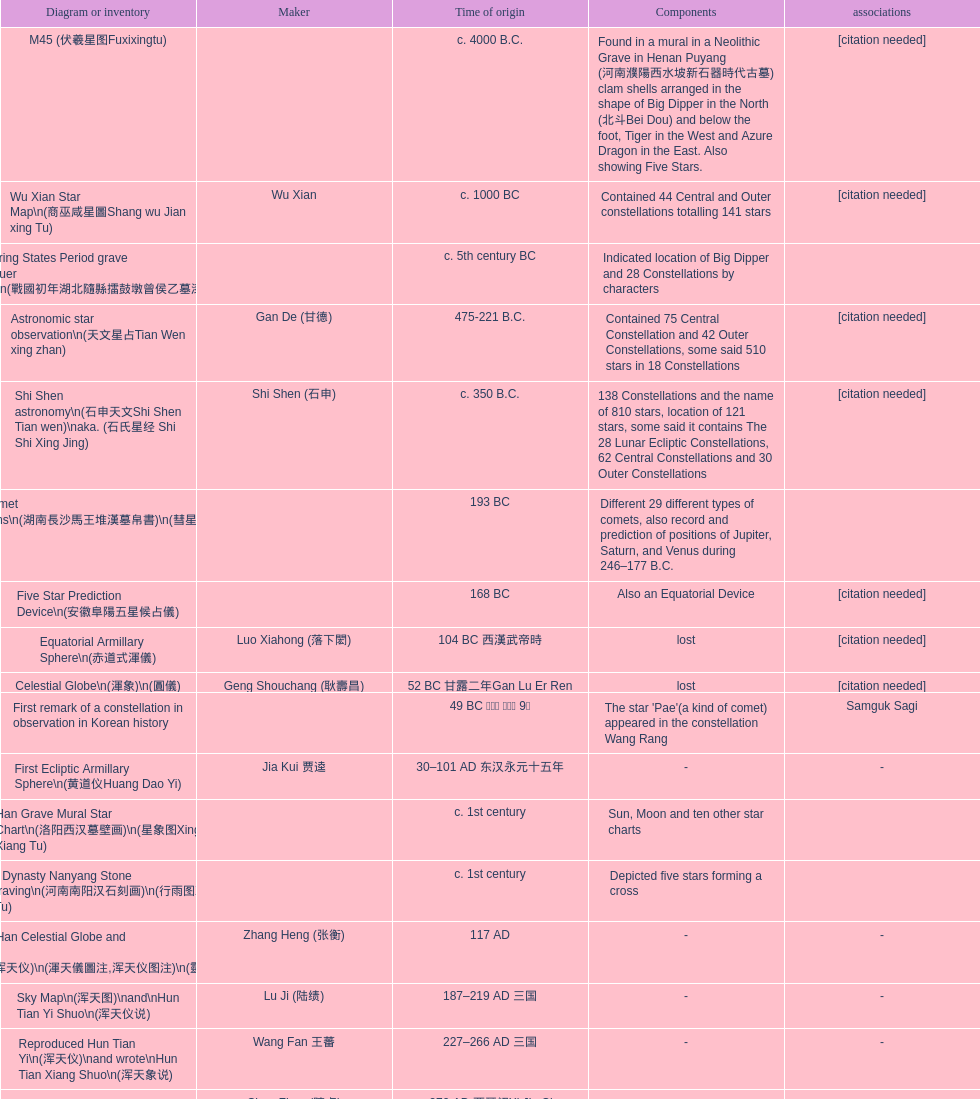Which star map was created earlier, celestial globe or the han grave mural star chart? Celestial Globe. 